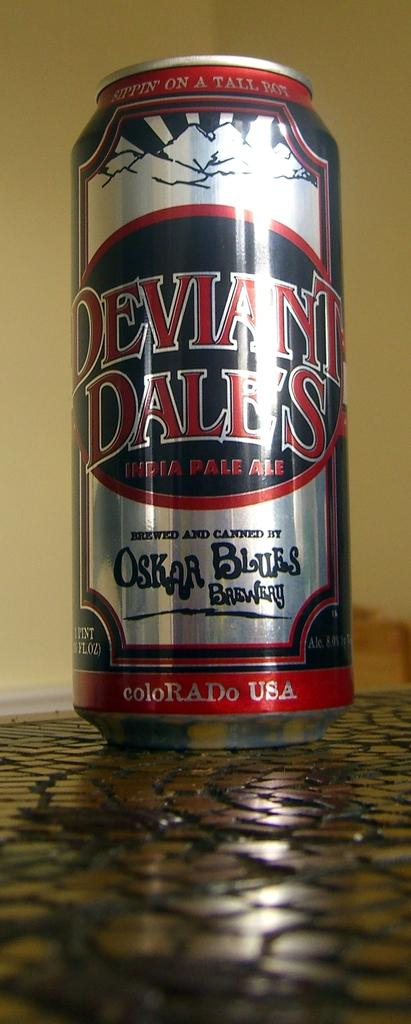Provide a one-sentence caption for the provided image. A tall can of Deviant Dale's India Pale Ale is sitting on a counter top.. 